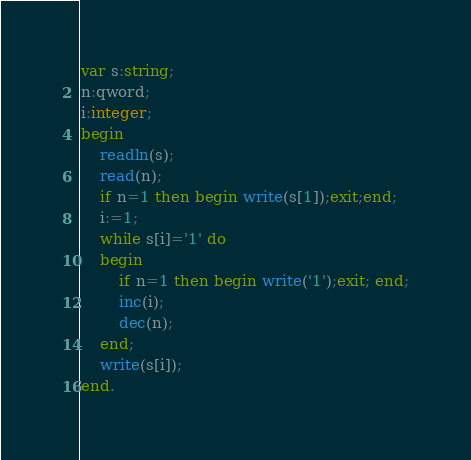<code> <loc_0><loc_0><loc_500><loc_500><_Pascal_>var s:string;
n:qword;
i:integer;
begin 
	readln(s);
	read(n);
	if n=1 then begin write(s[1]);exit;end;
	i:=1;
	while s[i]='1' do
	begin 
		if n=1 then begin write('1');exit; end;
		inc(i);
		dec(n);
	end;
	write(s[i]);
end.</code> 